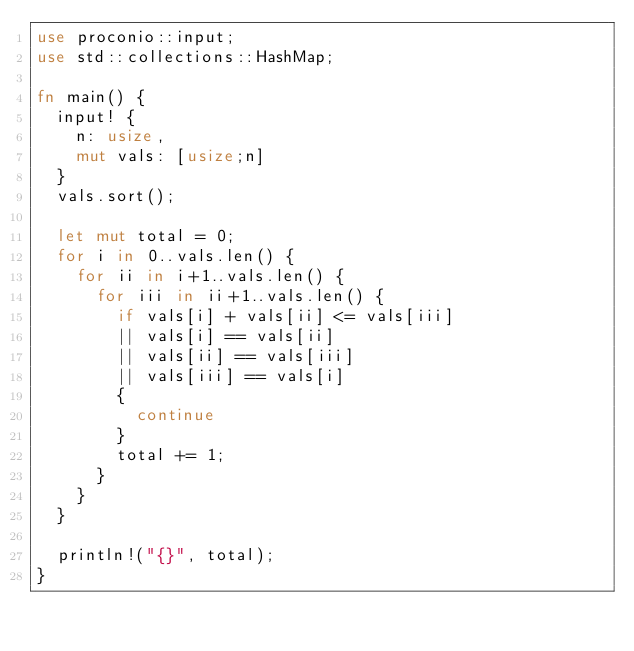Convert code to text. <code><loc_0><loc_0><loc_500><loc_500><_Rust_>use proconio::input;
use std::collections::HashMap;

fn main() {
  input! {
    n: usize,
    mut vals: [usize;n]
  }
  vals.sort();
  
  let mut total = 0;
  for i in 0..vals.len() {
    for ii in i+1..vals.len() {
      for iii in ii+1..vals.len() {
        if vals[i] + vals[ii] <= vals[iii]
        || vals[i] == vals[ii]
        || vals[ii] == vals[iii]
        || vals[iii] == vals[i]
        {
          continue
        }
        total += 1;
      }
    }
  }
  
  println!("{}", total);
}</code> 